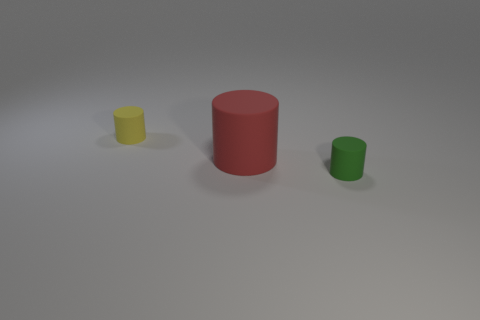Add 3 large purple rubber cylinders. How many objects exist? 6 Add 3 big rubber cylinders. How many big rubber cylinders exist? 4 Subtract 0 cyan blocks. How many objects are left? 3 Subtract all green cylinders. Subtract all small gray metallic spheres. How many objects are left? 2 Add 1 cylinders. How many cylinders are left? 4 